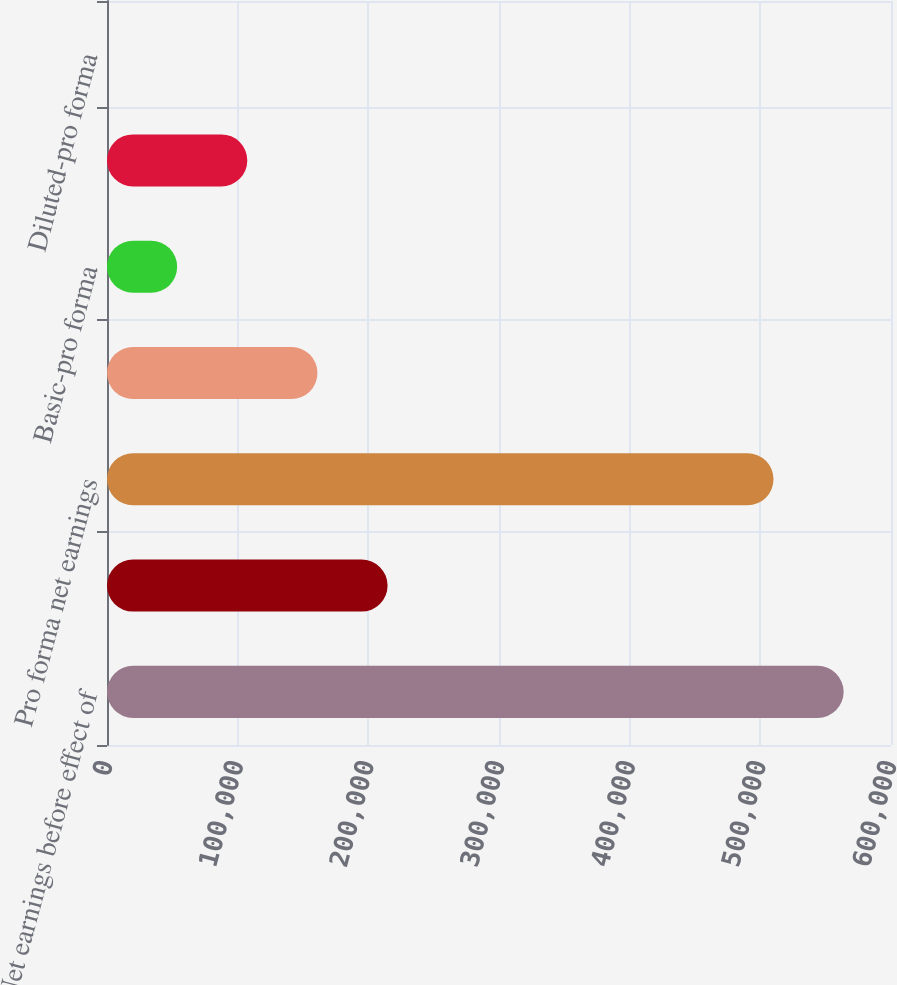<chart> <loc_0><loc_0><loc_500><loc_500><bar_chart><fcel>Net earnings before effect of<fcel>Deduct Stock-based employee<fcel>Pro forma net earnings<fcel>Basic-as reported<fcel>Basic-pro forma<fcel>Diluted-as reported<fcel>Diluted-pro forma<nl><fcel>563762<fcel>214735<fcel>510079<fcel>161051<fcel>53684.8<fcel>107368<fcel>1.6<nl></chart> 